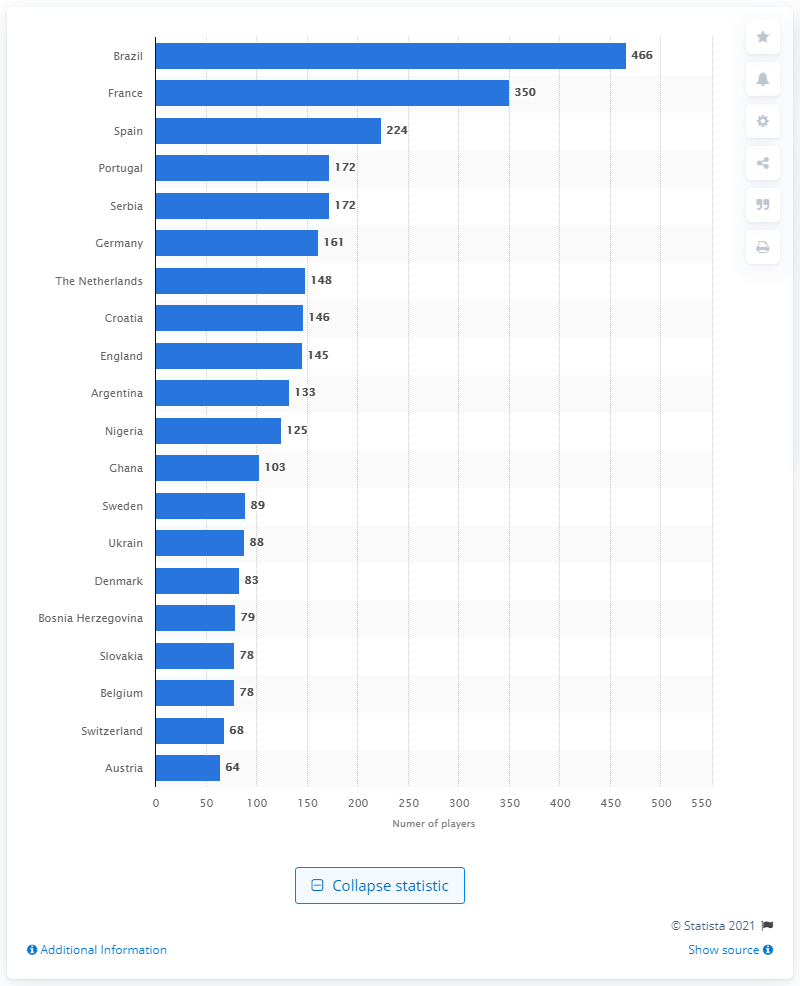Outline some significant characteristics in this image. As of November 2019, 466 Brazilian soccer players were active in the 31 European top divisions. 